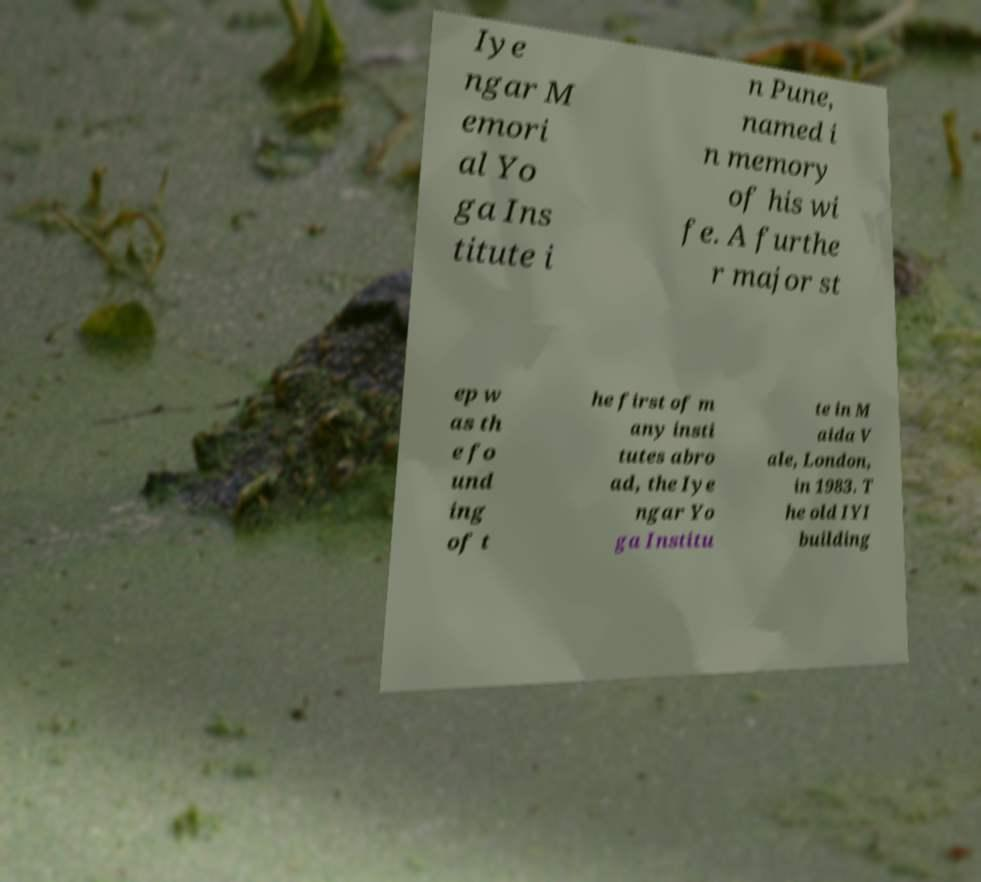Can you read and provide the text displayed in the image?This photo seems to have some interesting text. Can you extract and type it out for me? Iye ngar M emori al Yo ga Ins titute i n Pune, named i n memory of his wi fe. A furthe r major st ep w as th e fo und ing of t he first of m any insti tutes abro ad, the Iye ngar Yo ga Institu te in M aida V ale, London, in 1983. T he old IYI building 